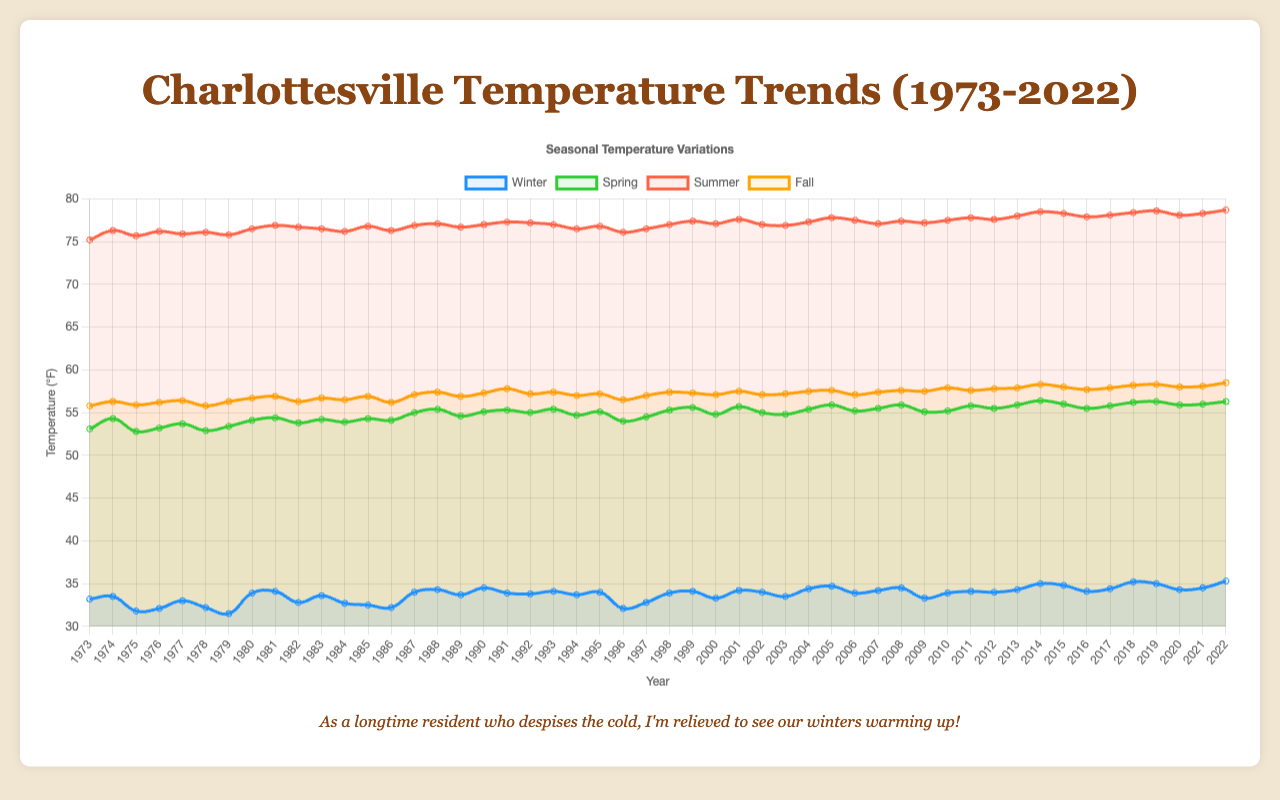Which season shows the highest average temperature trend over the last 50 years? By examining the temperature trends for each season, we can see that summer has consistently the highest temperatures across all years.
Answer: Summer How did the winter temperature in 1973 compare to the winter temperature in 2022? The winter temperature in 1973 was 33.2°F, while in 2022, it was 35.3°F. This shows an increase in winter temperature over the 50 years.
Answer: The winter temperature increased What is the average spring temperature for the years 2010 to 2022? To calculate the average, sum the spring temperatures from 2010 to 2022 (55.2 + 55.8 + 55.5 + 55.9 + 56.4 + 56.0 + 55.5 + 55.8 + 56.2 + 56.3 + 55.9 + 56.0 + 56.3) = 727.7; then divide by the number of years, 13. Thus, 727.7/13 = 55.98°F.
Answer: 55.98°F Which season had the smallest temperature increase over the 50 years? By comparing the start and end temperatures for each season: Winter increased from 33.2 to 35.3, Spring from 53.1 to 56.3, Summer from 75.2 to 78.7, and Fall from 55.8 to 58.5. The smallest increase is seen in winter (only 2.1°F).
Answer: Winter Between 1973 and 2022, which year had the highest recorded fall temperature and what was it? Reviewing the fall temperature data, the highest value is in 2022 which is 58.5°F.
Answer: 2022, 58.5°F How does the trend in spring temperatures from 1990 to 2000 compare to the trend from 2010 to 2020? First, calculate the differences in temperatures for each period: 1990 (55.1°F) to 2000 (55.9°F) gives a difference of 0.8°F. For 2010 (55.2°F) to 2020 (56.0°F), the difference is 0.8°F as well. Both periods show the same increase in spring temperatures.
Answer: The trends are the same What is the average temperature difference between summer and winter in 2022? The winter temperature for 2022 is 35.3°F, and the summer temperature is 78.7°F. The difference is 78.7 - 35.3 = 43.4°F.
Answer: 43.4°F Which season showed the most consistent temperature trend (least variability) over the 50 years? By assessing the visual representation and noting the less variable line, we see that fall has the least variability as its line is the smoothest and least fluctuating.
Answer: Fall Is there a notable difference in temperature trends between spring and fall? Comparing the trends in the time series, both spring and fall show a gradual increase, but spring displays a slightly more significant warming trend with a higher overall rise in temperature versus fall.
Answer: Spring shows a slightly more significant warming trend 